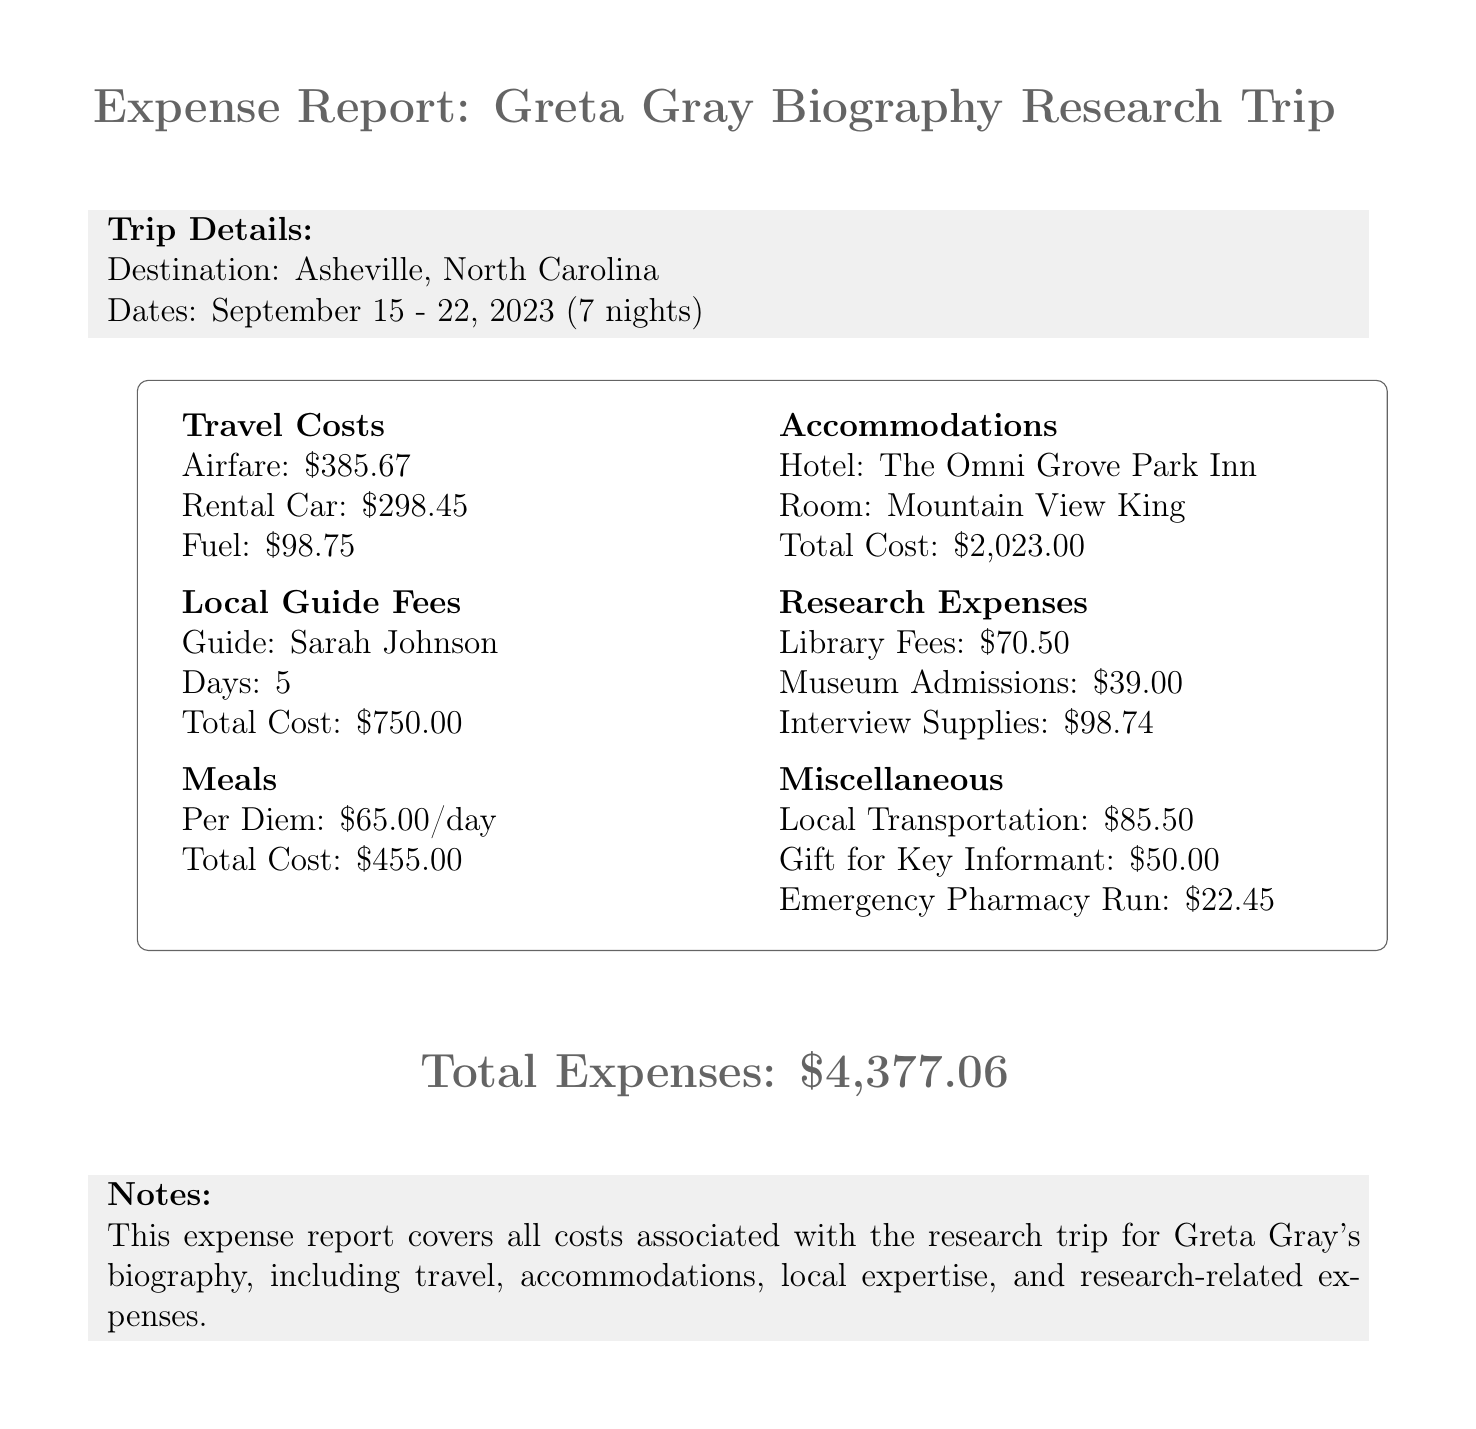What was the purpose of the trip? The purpose of the trip is specified in the document and is to conduct research related to Greta Gray.
Answer: Research trip to Greta Gray's hometown What is the total cost of accommodation? The total cost for the hotel accommodation is detailed in the accommodations section of the document.
Answer: 2023.00 Who was the local guide? The name of the local guide is mentioned in the local guide fees section.
Answer: Sarah Johnson How many days was the local guide hired? The document states the number of days the local guide was hired under local guide fees.
Answer: 5 What was the airfare amount? The airfare cost is provided in the travel costs section of the document.
Answer: 385.67 What is the total cost of meals? The meals section specifies the total cost for all meals incurred during the trip.
Answer: 455.00 How much was spent on fuel? The total cost for fuel is listed in the travel costs section.
Answer: 98.75 What was the daily rate for the guide? The daily rate for the local guide is provided in the local guide fees section.
Answer: 150.00 What was the total expense of the trip? The total expenses for the trip are summarized at the end of the document.
Answer: 4377.06 